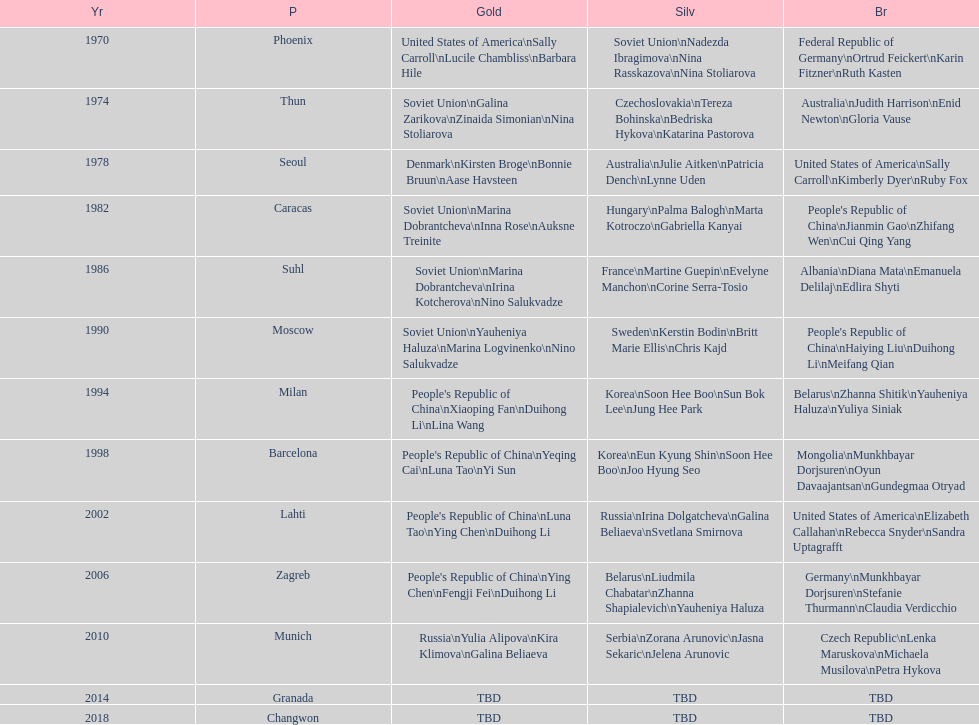What are the total number of times the soviet union is listed under the gold column? 4. 